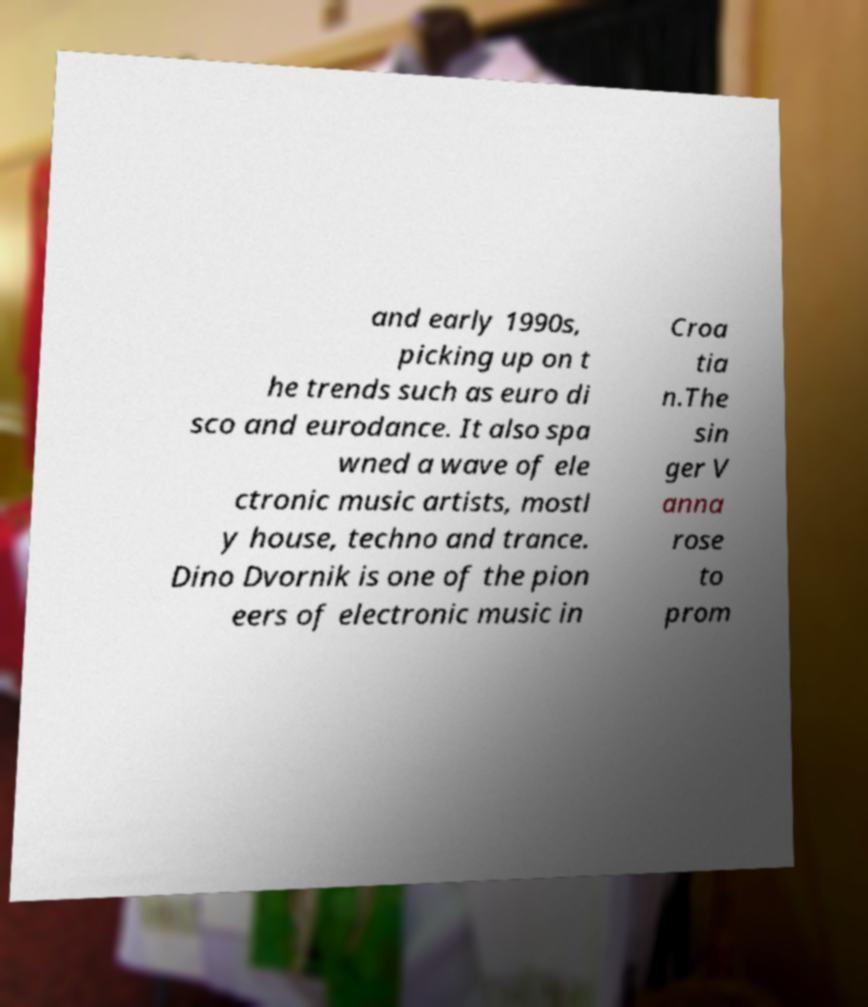I need the written content from this picture converted into text. Can you do that? and early 1990s, picking up on t he trends such as euro di sco and eurodance. It also spa wned a wave of ele ctronic music artists, mostl y house, techno and trance. Dino Dvornik is one of the pion eers of electronic music in Croa tia n.The sin ger V anna rose to prom 